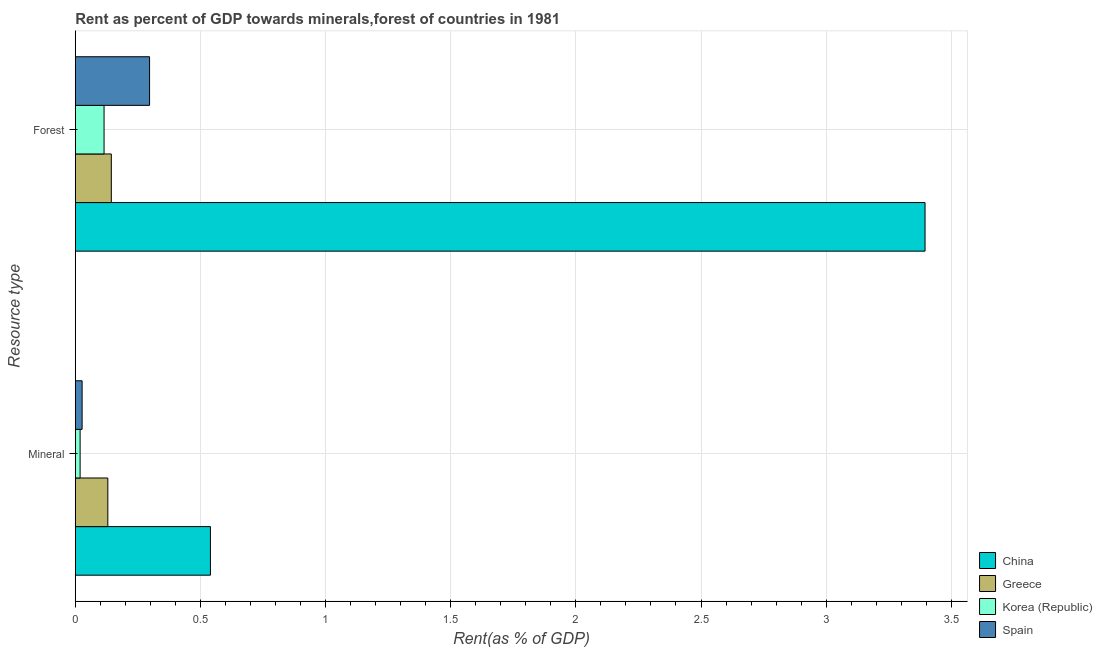How many different coloured bars are there?
Ensure brevity in your answer.  4. Are the number of bars per tick equal to the number of legend labels?
Keep it short and to the point. Yes. How many bars are there on the 1st tick from the top?
Your answer should be compact. 4. What is the label of the 2nd group of bars from the top?
Your answer should be compact. Mineral. What is the mineral rent in Greece?
Offer a very short reply. 0.13. Across all countries, what is the maximum forest rent?
Your answer should be very brief. 3.4. Across all countries, what is the minimum forest rent?
Make the answer very short. 0.11. In which country was the forest rent maximum?
Provide a short and direct response. China. In which country was the mineral rent minimum?
Your answer should be very brief. Korea (Republic). What is the total forest rent in the graph?
Offer a terse response. 3.95. What is the difference between the mineral rent in China and that in Spain?
Provide a succinct answer. 0.51. What is the difference between the mineral rent in Greece and the forest rent in Spain?
Provide a short and direct response. -0.17. What is the average forest rent per country?
Give a very brief answer. 0.99. What is the difference between the mineral rent and forest rent in China?
Ensure brevity in your answer.  -2.86. What is the ratio of the forest rent in Korea (Republic) to that in China?
Your answer should be very brief. 0.03. In how many countries, is the forest rent greater than the average forest rent taken over all countries?
Your response must be concise. 1. What does the 3rd bar from the bottom in Forest represents?
Your answer should be very brief. Korea (Republic). How many bars are there?
Offer a terse response. 8. How many countries are there in the graph?
Provide a succinct answer. 4. What is the difference between two consecutive major ticks on the X-axis?
Give a very brief answer. 0.5. Does the graph contain any zero values?
Provide a succinct answer. No. How many legend labels are there?
Your answer should be compact. 4. What is the title of the graph?
Your answer should be compact. Rent as percent of GDP towards minerals,forest of countries in 1981. What is the label or title of the X-axis?
Your answer should be compact. Rent(as % of GDP). What is the label or title of the Y-axis?
Your answer should be very brief. Resource type. What is the Rent(as % of GDP) of China in Mineral?
Offer a terse response. 0.54. What is the Rent(as % of GDP) of Greece in Mineral?
Offer a very short reply. 0.13. What is the Rent(as % of GDP) of Korea (Republic) in Mineral?
Offer a terse response. 0.02. What is the Rent(as % of GDP) of Spain in Mineral?
Your answer should be compact. 0.03. What is the Rent(as % of GDP) in China in Forest?
Your answer should be compact. 3.4. What is the Rent(as % of GDP) in Greece in Forest?
Your answer should be very brief. 0.14. What is the Rent(as % of GDP) of Korea (Republic) in Forest?
Your response must be concise. 0.11. What is the Rent(as % of GDP) in Spain in Forest?
Offer a very short reply. 0.3. Across all Resource type, what is the maximum Rent(as % of GDP) in China?
Provide a succinct answer. 3.4. Across all Resource type, what is the maximum Rent(as % of GDP) of Greece?
Keep it short and to the point. 0.14. Across all Resource type, what is the maximum Rent(as % of GDP) in Korea (Republic)?
Offer a terse response. 0.11. Across all Resource type, what is the maximum Rent(as % of GDP) of Spain?
Give a very brief answer. 0.3. Across all Resource type, what is the minimum Rent(as % of GDP) in China?
Your response must be concise. 0.54. Across all Resource type, what is the minimum Rent(as % of GDP) in Greece?
Your answer should be compact. 0.13. Across all Resource type, what is the minimum Rent(as % of GDP) of Korea (Republic)?
Keep it short and to the point. 0.02. Across all Resource type, what is the minimum Rent(as % of GDP) in Spain?
Make the answer very short. 0.03. What is the total Rent(as % of GDP) of China in the graph?
Your answer should be compact. 3.94. What is the total Rent(as % of GDP) in Greece in the graph?
Your response must be concise. 0.27. What is the total Rent(as % of GDP) in Korea (Republic) in the graph?
Your response must be concise. 0.13. What is the total Rent(as % of GDP) of Spain in the graph?
Provide a short and direct response. 0.32. What is the difference between the Rent(as % of GDP) of China in Mineral and that in Forest?
Provide a short and direct response. -2.86. What is the difference between the Rent(as % of GDP) in Greece in Mineral and that in Forest?
Provide a succinct answer. -0.01. What is the difference between the Rent(as % of GDP) of Korea (Republic) in Mineral and that in Forest?
Give a very brief answer. -0.1. What is the difference between the Rent(as % of GDP) in Spain in Mineral and that in Forest?
Make the answer very short. -0.27. What is the difference between the Rent(as % of GDP) in China in Mineral and the Rent(as % of GDP) in Greece in Forest?
Keep it short and to the point. 0.4. What is the difference between the Rent(as % of GDP) of China in Mineral and the Rent(as % of GDP) of Korea (Republic) in Forest?
Give a very brief answer. 0.42. What is the difference between the Rent(as % of GDP) in China in Mineral and the Rent(as % of GDP) in Spain in Forest?
Keep it short and to the point. 0.24. What is the difference between the Rent(as % of GDP) in Greece in Mineral and the Rent(as % of GDP) in Korea (Republic) in Forest?
Offer a terse response. 0.02. What is the difference between the Rent(as % of GDP) in Greece in Mineral and the Rent(as % of GDP) in Spain in Forest?
Your answer should be compact. -0.17. What is the difference between the Rent(as % of GDP) of Korea (Republic) in Mineral and the Rent(as % of GDP) of Spain in Forest?
Provide a short and direct response. -0.28. What is the average Rent(as % of GDP) of China per Resource type?
Give a very brief answer. 1.97. What is the average Rent(as % of GDP) in Greece per Resource type?
Give a very brief answer. 0.14. What is the average Rent(as % of GDP) in Korea (Republic) per Resource type?
Keep it short and to the point. 0.07. What is the average Rent(as % of GDP) in Spain per Resource type?
Ensure brevity in your answer.  0.16. What is the difference between the Rent(as % of GDP) in China and Rent(as % of GDP) in Greece in Mineral?
Ensure brevity in your answer.  0.41. What is the difference between the Rent(as % of GDP) of China and Rent(as % of GDP) of Korea (Republic) in Mineral?
Provide a succinct answer. 0.52. What is the difference between the Rent(as % of GDP) of China and Rent(as % of GDP) of Spain in Mineral?
Keep it short and to the point. 0.51. What is the difference between the Rent(as % of GDP) of Greece and Rent(as % of GDP) of Korea (Republic) in Mineral?
Offer a terse response. 0.11. What is the difference between the Rent(as % of GDP) of Greece and Rent(as % of GDP) of Spain in Mineral?
Provide a short and direct response. 0.1. What is the difference between the Rent(as % of GDP) in Korea (Republic) and Rent(as % of GDP) in Spain in Mineral?
Your answer should be very brief. -0.01. What is the difference between the Rent(as % of GDP) of China and Rent(as % of GDP) of Greece in Forest?
Offer a terse response. 3.25. What is the difference between the Rent(as % of GDP) in China and Rent(as % of GDP) in Korea (Republic) in Forest?
Keep it short and to the point. 3.28. What is the difference between the Rent(as % of GDP) of China and Rent(as % of GDP) of Spain in Forest?
Give a very brief answer. 3.1. What is the difference between the Rent(as % of GDP) in Greece and Rent(as % of GDP) in Korea (Republic) in Forest?
Ensure brevity in your answer.  0.03. What is the difference between the Rent(as % of GDP) in Greece and Rent(as % of GDP) in Spain in Forest?
Offer a terse response. -0.15. What is the difference between the Rent(as % of GDP) in Korea (Republic) and Rent(as % of GDP) in Spain in Forest?
Keep it short and to the point. -0.18. What is the ratio of the Rent(as % of GDP) in China in Mineral to that in Forest?
Offer a very short reply. 0.16. What is the ratio of the Rent(as % of GDP) in Greece in Mineral to that in Forest?
Offer a very short reply. 0.9. What is the ratio of the Rent(as % of GDP) of Korea (Republic) in Mineral to that in Forest?
Give a very brief answer. 0.17. What is the ratio of the Rent(as % of GDP) of Spain in Mineral to that in Forest?
Your answer should be very brief. 0.09. What is the difference between the highest and the second highest Rent(as % of GDP) of China?
Your answer should be very brief. 2.86. What is the difference between the highest and the second highest Rent(as % of GDP) in Greece?
Offer a very short reply. 0.01. What is the difference between the highest and the second highest Rent(as % of GDP) in Korea (Republic)?
Your answer should be very brief. 0.1. What is the difference between the highest and the second highest Rent(as % of GDP) of Spain?
Keep it short and to the point. 0.27. What is the difference between the highest and the lowest Rent(as % of GDP) in China?
Offer a terse response. 2.86. What is the difference between the highest and the lowest Rent(as % of GDP) in Greece?
Provide a succinct answer. 0.01. What is the difference between the highest and the lowest Rent(as % of GDP) of Korea (Republic)?
Offer a very short reply. 0.1. What is the difference between the highest and the lowest Rent(as % of GDP) in Spain?
Your response must be concise. 0.27. 